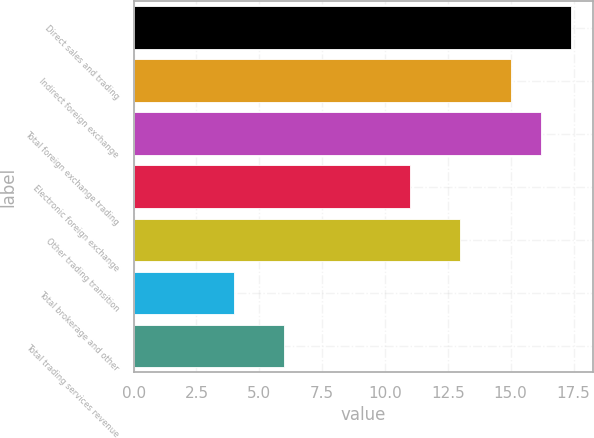<chart> <loc_0><loc_0><loc_500><loc_500><bar_chart><fcel>Direct sales and trading<fcel>Indirect foreign exchange<fcel>Total foreign exchange trading<fcel>Electronic foreign exchange<fcel>Other trading transition<fcel>Total brokerage and other<fcel>Total trading services revenue<nl><fcel>17.4<fcel>15<fcel>16.2<fcel>11<fcel>13<fcel>4<fcel>6<nl></chart> 